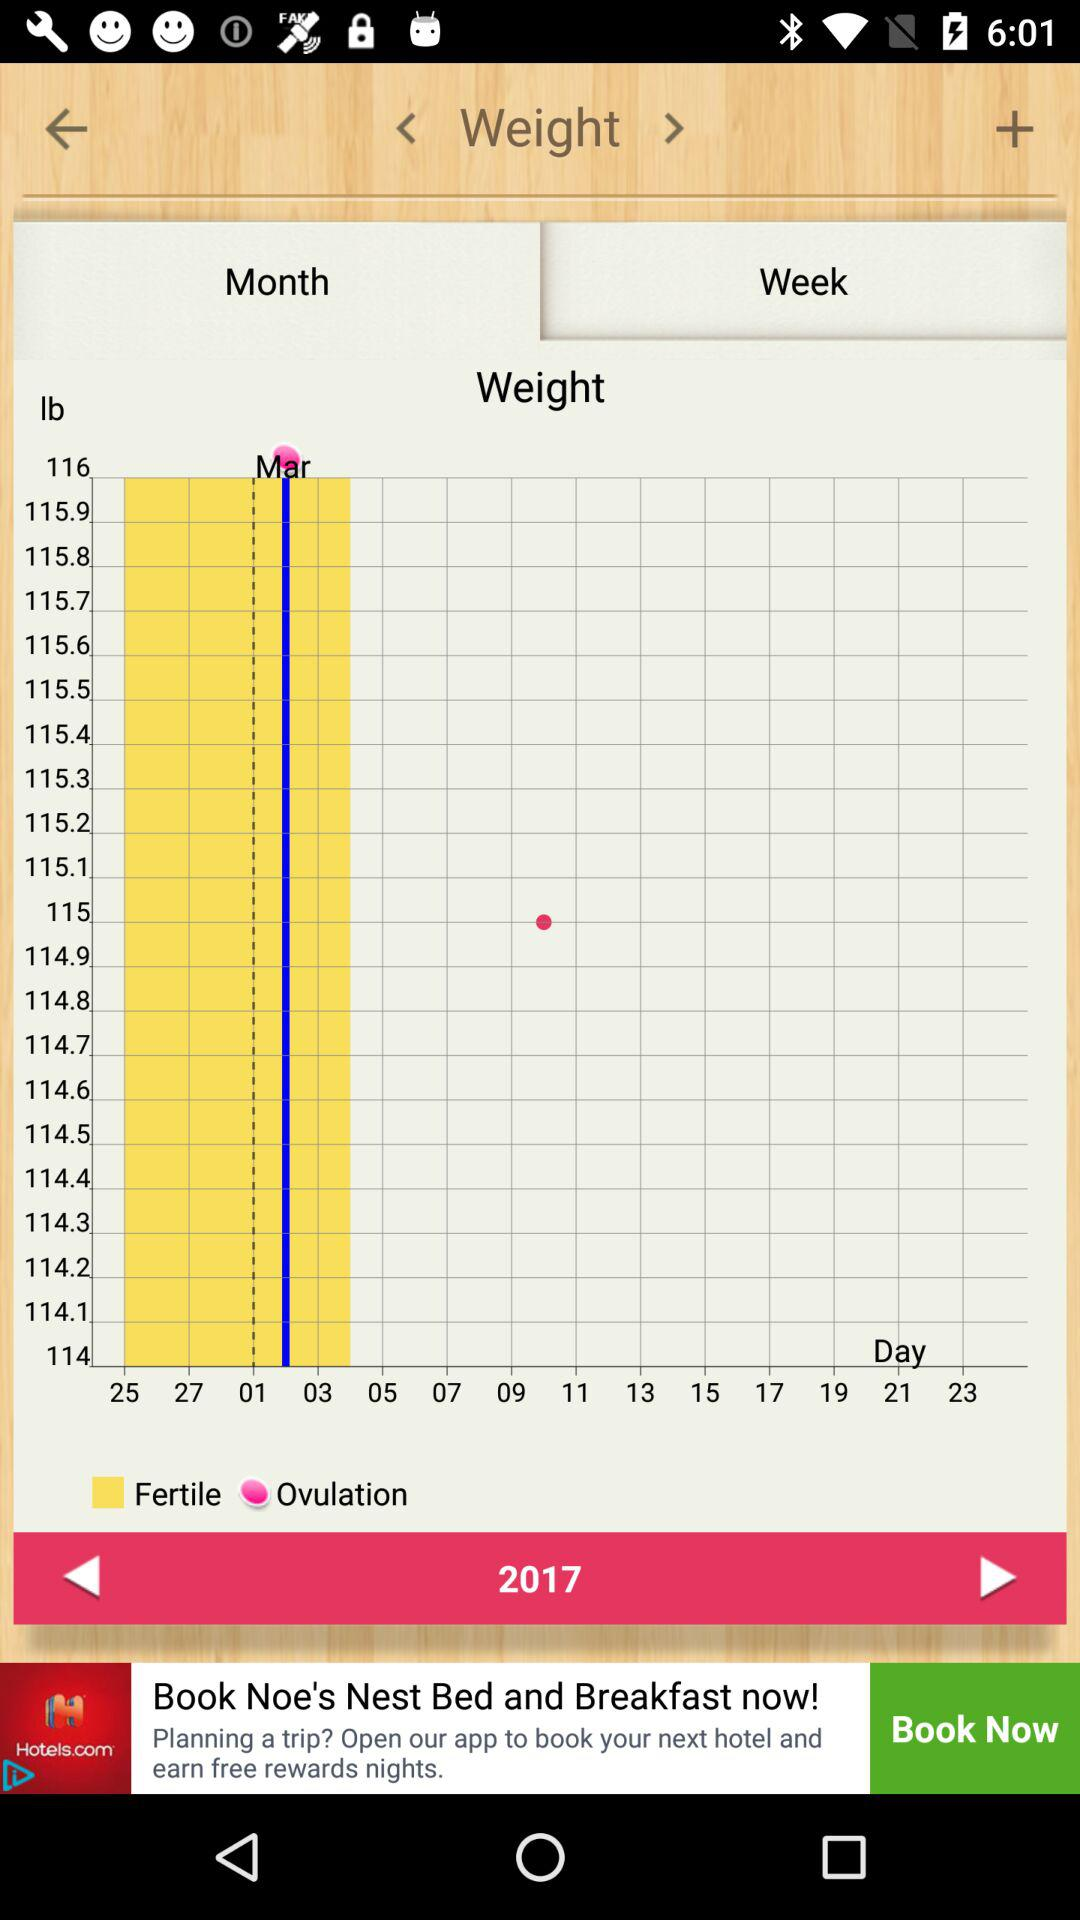What is the shown year? The shown year is 2017. 